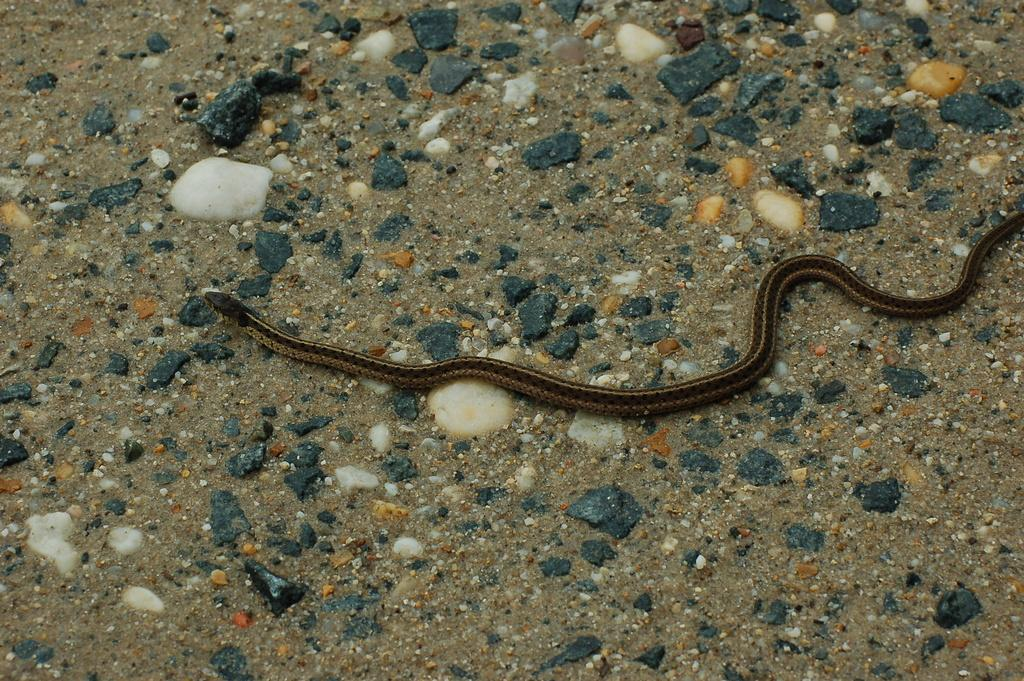What type of animal is in the image? There is a snake in the image. What else can be seen in the image besides the snake? There are stones in the image. Can you tell me how many times the girl jumps over the cast in the image? There is no girl, cast, or jumping activity present in the image; it only features a snake and stones. 